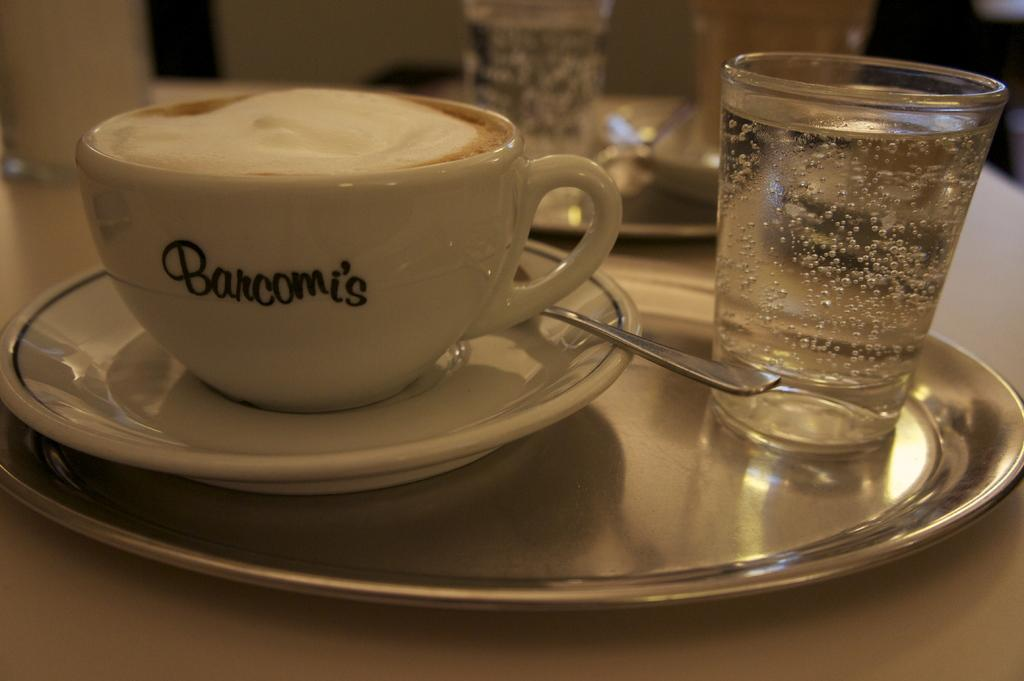What piece of furniture is present in the image? There is a table in the image. What is placed on the table? There is a plate on the table. What items are on the plate? There is a cup, a spoon, and a glass on the plate. Is there another glass visible in the image? Yes, there is another glass behind the plate. What type of test is being conducted on the duck in the image? There is no duck present in the image, and therefore no test is being conducted. 